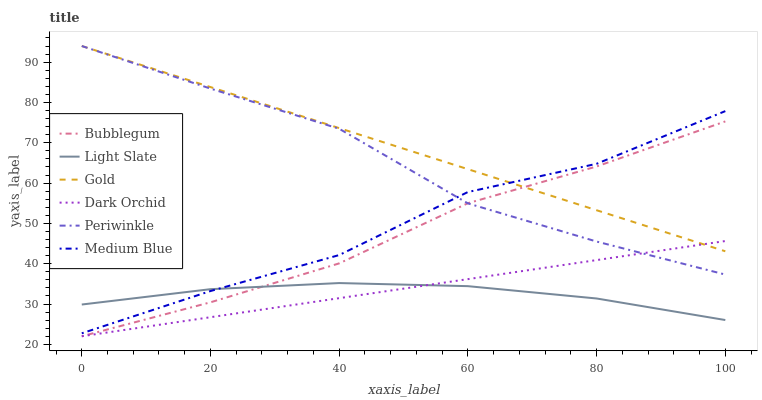Does Light Slate have the minimum area under the curve?
Answer yes or no. Yes. Does Gold have the maximum area under the curve?
Answer yes or no. Yes. Does Medium Blue have the minimum area under the curve?
Answer yes or no. No. Does Medium Blue have the maximum area under the curve?
Answer yes or no. No. Is Dark Orchid the smoothest?
Answer yes or no. Yes. Is Medium Blue the roughest?
Answer yes or no. Yes. Is Light Slate the smoothest?
Answer yes or no. No. Is Light Slate the roughest?
Answer yes or no. No. Does Dark Orchid have the lowest value?
Answer yes or no. Yes. Does Light Slate have the lowest value?
Answer yes or no. No. Does Periwinkle have the highest value?
Answer yes or no. Yes. Does Medium Blue have the highest value?
Answer yes or no. No. Is Light Slate less than Periwinkle?
Answer yes or no. Yes. Is Gold greater than Light Slate?
Answer yes or no. Yes. Does Periwinkle intersect Gold?
Answer yes or no. Yes. Is Periwinkle less than Gold?
Answer yes or no. No. Is Periwinkle greater than Gold?
Answer yes or no. No. Does Light Slate intersect Periwinkle?
Answer yes or no. No. 